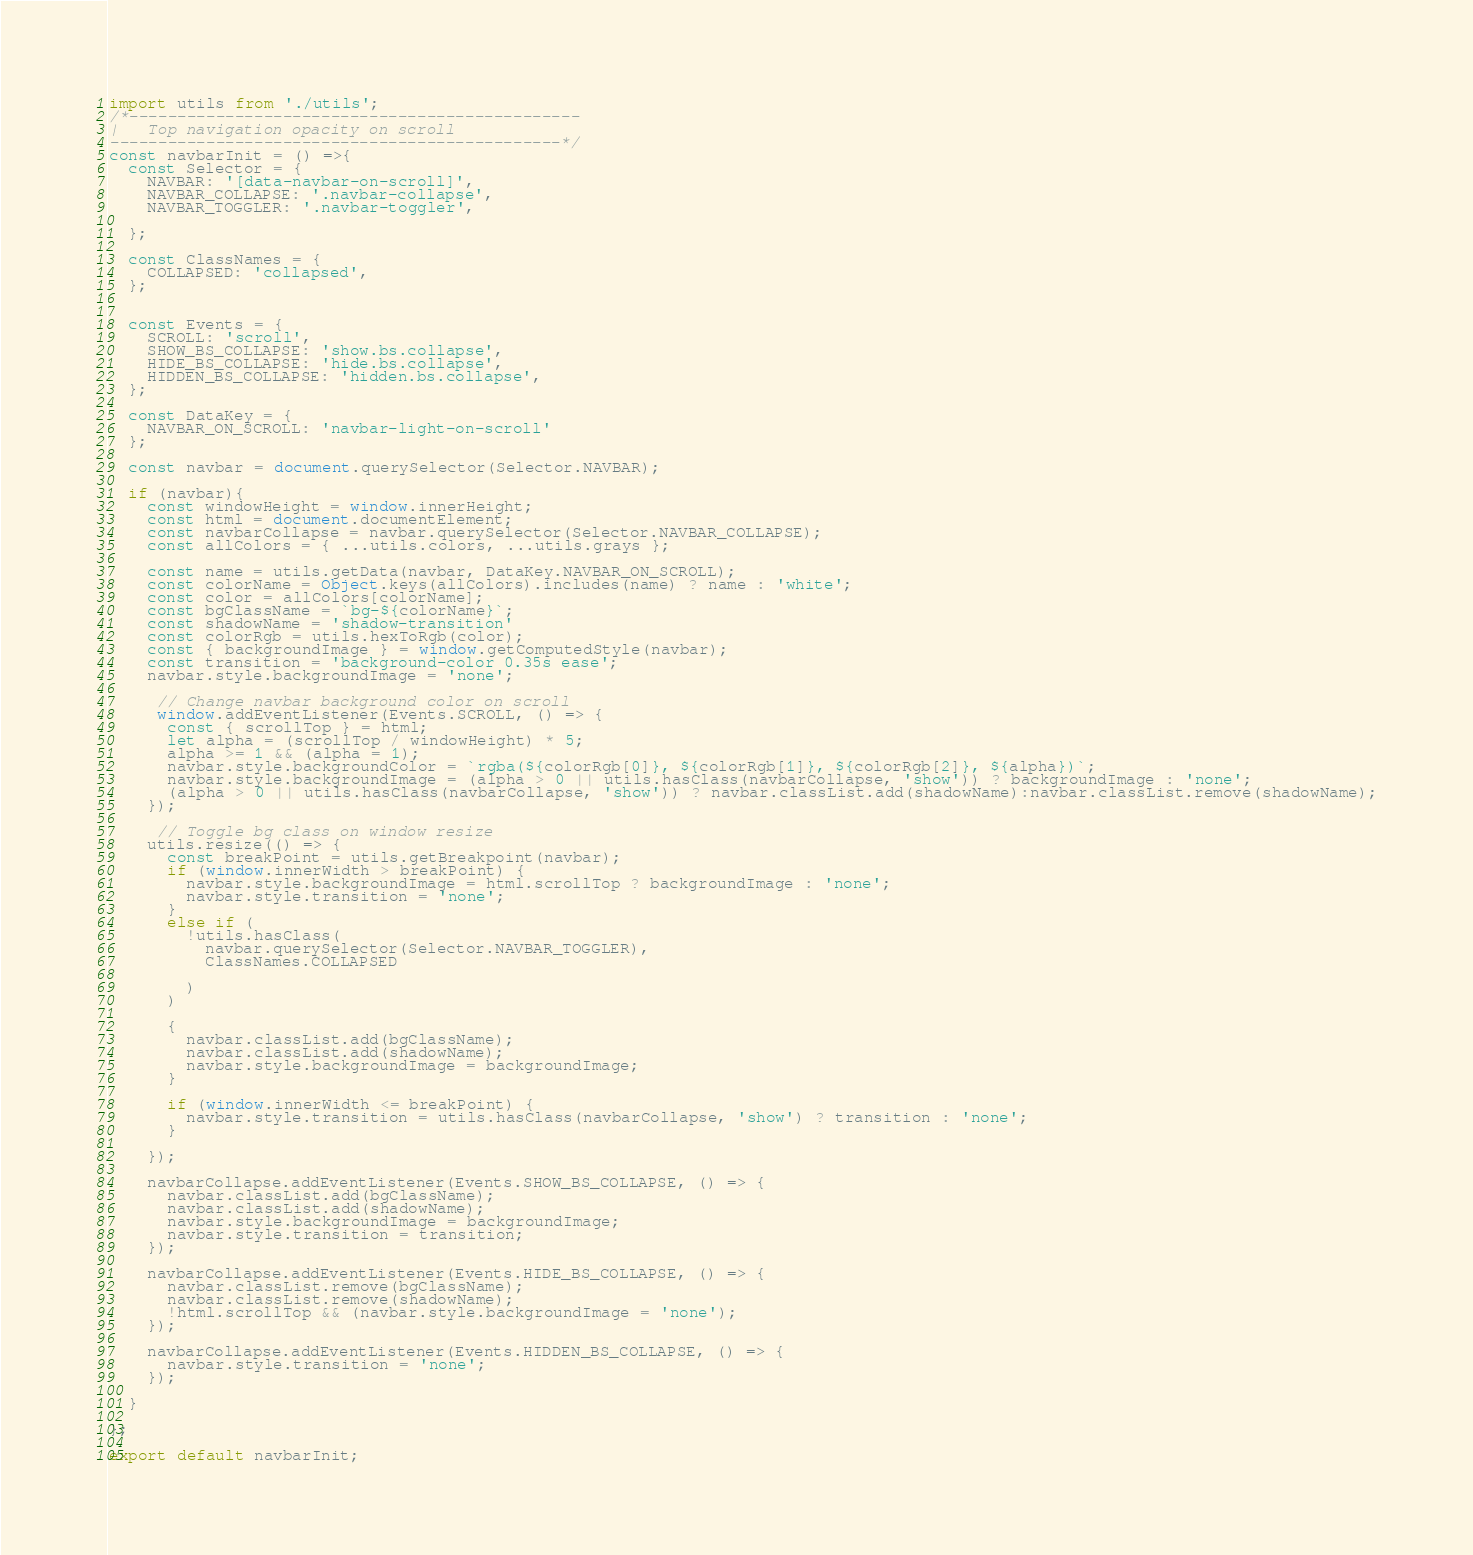<code> <loc_0><loc_0><loc_500><loc_500><_JavaScript_>import utils from './utils';
/*-----------------------------------------------
|   Top navigation opacity on scroll
-----------------------------------------------*/
const navbarInit = () =>{
  const Selector = {
    NAVBAR: '[data-navbar-on-scroll]',
    NAVBAR_COLLAPSE: '.navbar-collapse',
    NAVBAR_TOGGLER: '.navbar-toggler',
    
  };

  const ClassNames = {
    COLLAPSED: 'collapsed',
  };

  
  const Events = {
    SCROLL: 'scroll',
    SHOW_BS_COLLAPSE: 'show.bs.collapse',
    HIDE_BS_COLLAPSE: 'hide.bs.collapse',
    HIDDEN_BS_COLLAPSE: 'hidden.bs.collapse',
  };

  const DataKey = {
    NAVBAR_ON_SCROLL: 'navbar-light-on-scroll'
  };
  
  const navbar = document.querySelector(Selector.NAVBAR);
  
  if (navbar){
    const windowHeight = window.innerHeight;
    const html = document.documentElement;
    const navbarCollapse = navbar.querySelector(Selector.NAVBAR_COLLAPSE);
    const allColors = { ...utils.colors, ...utils.grays };

    const name = utils.getData(navbar, DataKey.NAVBAR_ON_SCROLL);
    const colorName = Object.keys(allColors).includes(name) ? name : 'white';
    const color = allColors[colorName];
    const bgClassName = `bg-${colorName}`;
    const shadowName = 'shadow-transition'
    const colorRgb = utils.hexToRgb(color);
    const { backgroundImage } = window.getComputedStyle(navbar);
    const transition = 'background-color 0.35s ease';
    navbar.style.backgroundImage = 'none';

     // Change navbar background color on scroll
     window.addEventListener(Events.SCROLL, () => {
      const { scrollTop } = html;
      let alpha = (scrollTop / windowHeight) * 5;
      alpha >= 1 && (alpha = 1);
      navbar.style.backgroundColor = `rgba(${colorRgb[0]}, ${colorRgb[1]}, ${colorRgb[2]}, ${alpha})`;
      navbar.style.backgroundImage = (alpha > 0 || utils.hasClass(navbarCollapse, 'show')) ? backgroundImage : 'none';
      (alpha > 0 || utils.hasClass(navbarCollapse, 'show')) ? navbar.classList.add(shadowName):navbar.classList.remove(shadowName);
    });

     // Toggle bg class on window resize
    utils.resize(() => {
      const breakPoint = utils.getBreakpoint(navbar);
      if (window.innerWidth > breakPoint) {
        navbar.style.backgroundImage = html.scrollTop ? backgroundImage : 'none';
        navbar.style.transition = 'none';
      } 
      else if (
        !utils.hasClass(
          navbar.querySelector(Selector.NAVBAR_TOGGLER),
          ClassNames.COLLAPSED
         
        )
      )

      { 
        navbar.classList.add(bgClassName);
        navbar.classList.add(shadowName);
        navbar.style.backgroundImage = backgroundImage;
      }
     
      if (window.innerWidth <= breakPoint) {
        navbar.style.transition = utils.hasClass(navbarCollapse, 'show') ? transition : 'none';
      } 

    });

    navbarCollapse.addEventListener(Events.SHOW_BS_COLLAPSE, () => {
      navbar.classList.add(bgClassName);
      navbar.classList.add(shadowName);
      navbar.style.backgroundImage = backgroundImage;
      navbar.style.transition = transition;
    });

    navbarCollapse.addEventListener(Events.HIDE_BS_COLLAPSE, () => {
      navbar.classList.remove(bgClassName);
      navbar.classList.remove(shadowName);
      !html.scrollTop && (navbar.style.backgroundImage = 'none');
    });

    navbarCollapse.addEventListener(Events.HIDDEN_BS_COLLAPSE, () => {
      navbar.style.transition = 'none';
    });

  }

};

export default navbarInit;





</code> 